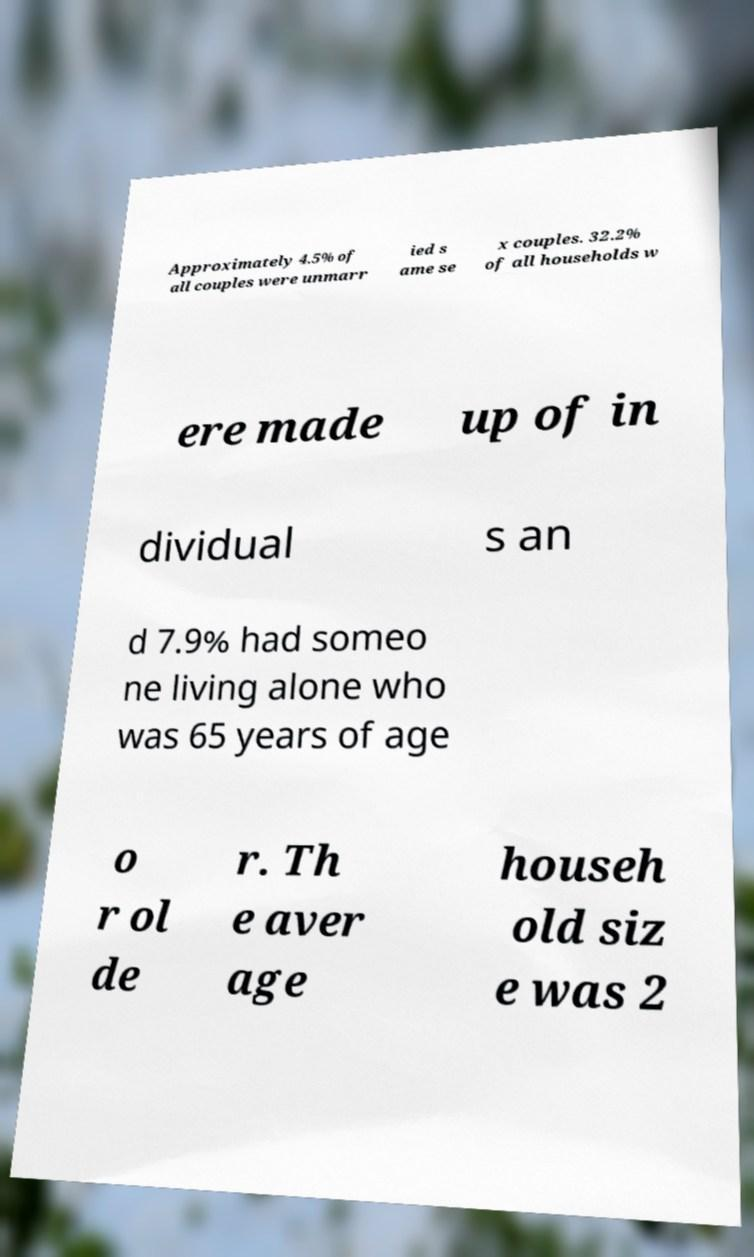For documentation purposes, I need the text within this image transcribed. Could you provide that? Approximately 4.5% of all couples were unmarr ied s ame se x couples. 32.2% of all households w ere made up of in dividual s an d 7.9% had someo ne living alone who was 65 years of age o r ol de r. Th e aver age househ old siz e was 2 